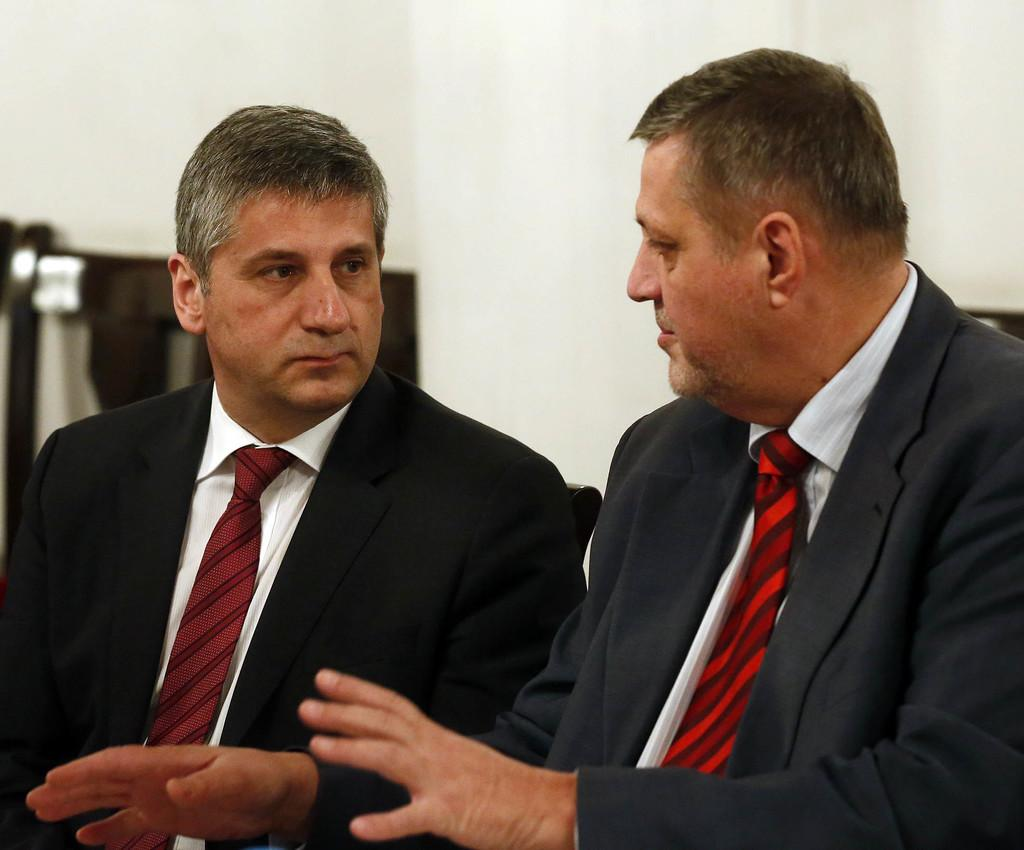How many people are in the image? There are two men in the image. What are the men wearing? The men are wearing black suits, white shirts, and ties. What can be seen in the background of the image? There is a white wall in the background of the image. What structure can be seen in the way the men are standing in the image? There is no structure visible in the image, and the men's stance does not form any specific shape or pattern. 